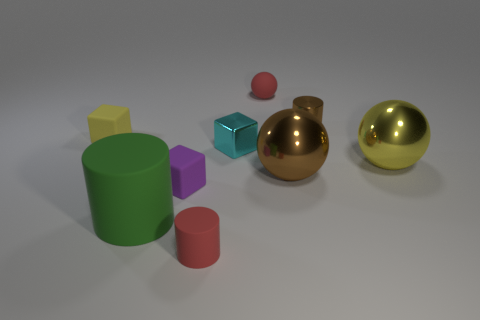Add 1 big gray shiny cylinders. How many objects exist? 10 Subtract all cylinders. How many objects are left? 6 Subtract 0 yellow cylinders. How many objects are left? 9 Subtract all metal objects. Subtract all tiny purple rubber objects. How many objects are left? 4 Add 7 brown metal cylinders. How many brown metal cylinders are left? 8 Add 3 large yellow balls. How many large yellow balls exist? 4 